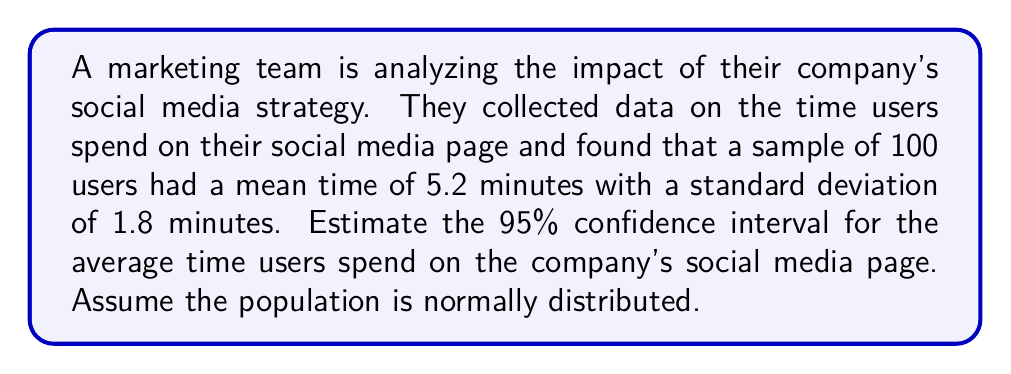Help me with this question. To estimate the confidence interval, we'll follow these steps:

1. Identify the given information:
   - Sample size: $n = 100$
   - Sample mean: $\bar{x} = 5.2$ minutes
   - Sample standard deviation: $s = 1.8$ minutes
   - Confidence level: 95% (α = 0.05)

2. Determine the critical value:
   For a 95% confidence interval, we use $z_{α/2} = 1.96$

3. Calculate the standard error of the mean:
   $SE_{\bar{x}} = \frac{s}{\sqrt{n}} = \frac{1.8}{\sqrt{100}} = 0.18$

4. Compute the margin of error:
   $E = z_{α/2} \cdot SE_{\bar{x}} = 1.96 \cdot 0.18 = 0.3528$

5. Calculate the confidence interval:
   Lower bound: $\bar{x} - E = 5.2 - 0.3528 = 4.8472$
   Upper bound: $\bar{x} + E = 5.2 + 0.3528 = 5.5528$

Therefore, the 95% confidence interval is (4.8472, 5.5528) minutes.

This means we can be 95% confident that the true population mean time users spend on the company's social media page falls between 4.8472 and 5.5528 minutes.
Answer: (4.8472, 5.5528) minutes 